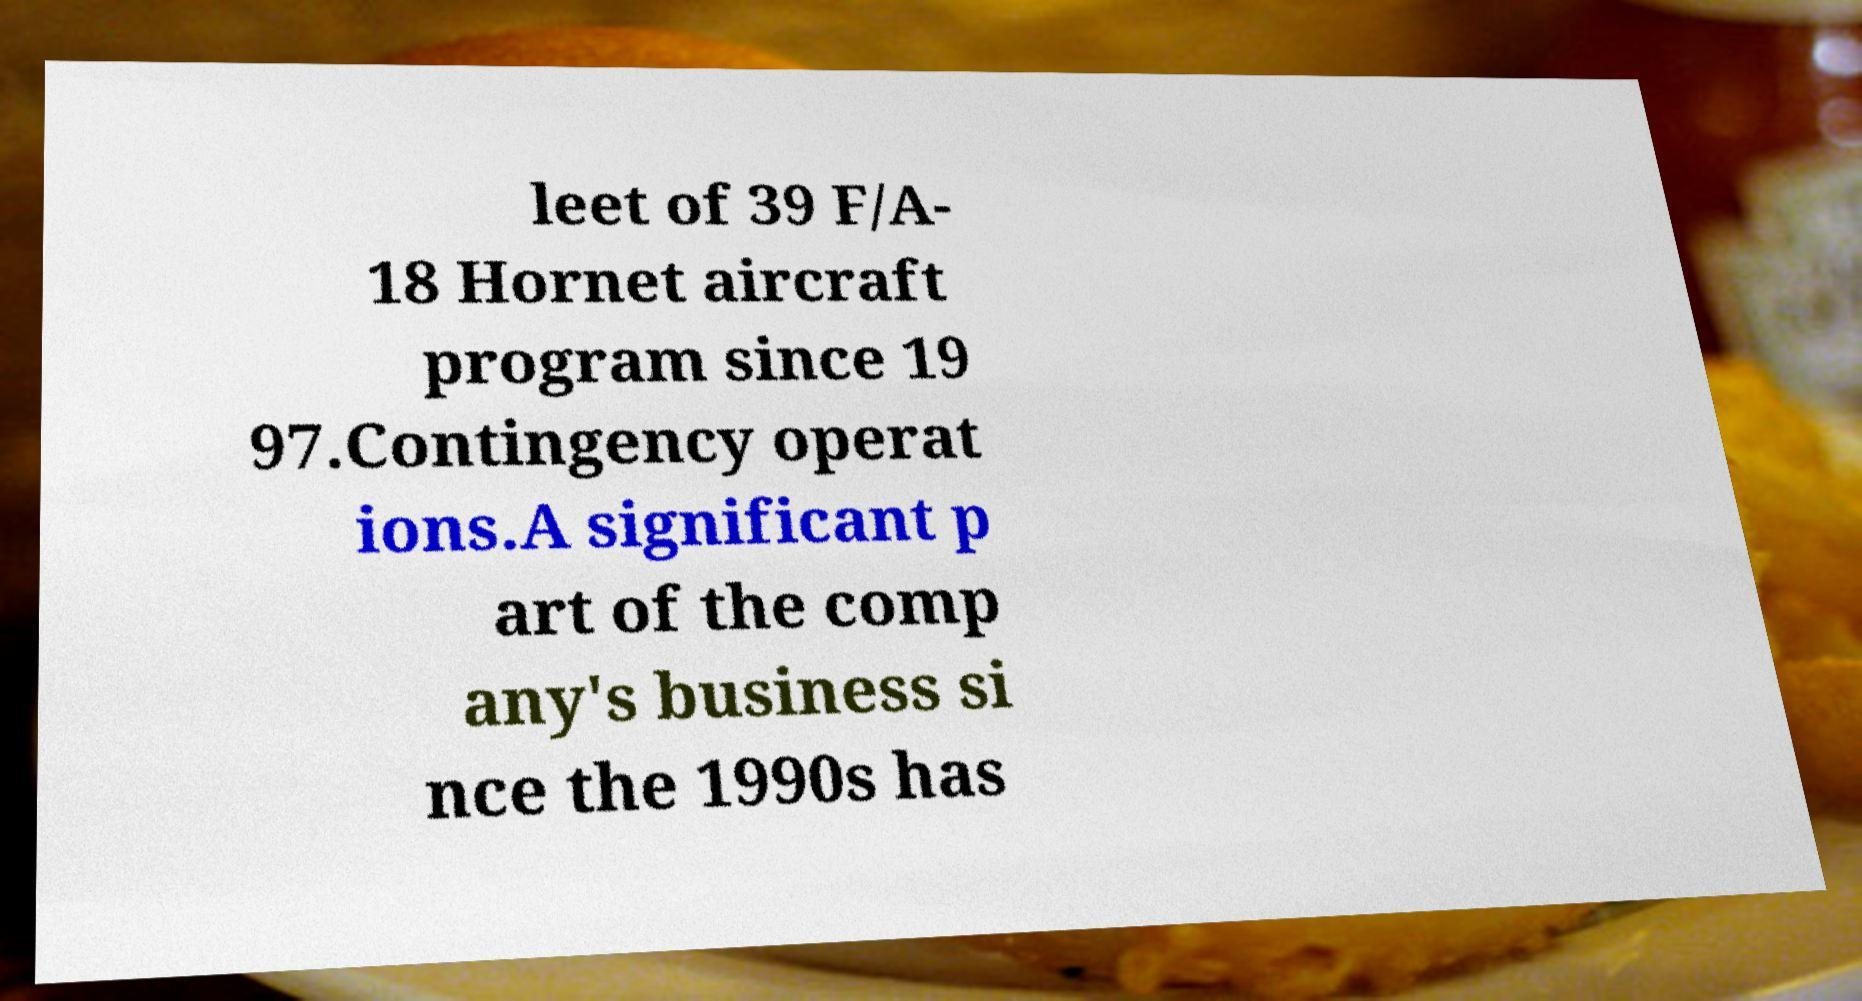What messages or text are displayed in this image? I need them in a readable, typed format. leet of 39 F/A- 18 Hornet aircraft program since 19 97.Contingency operat ions.A significant p art of the comp any's business si nce the 1990s has 